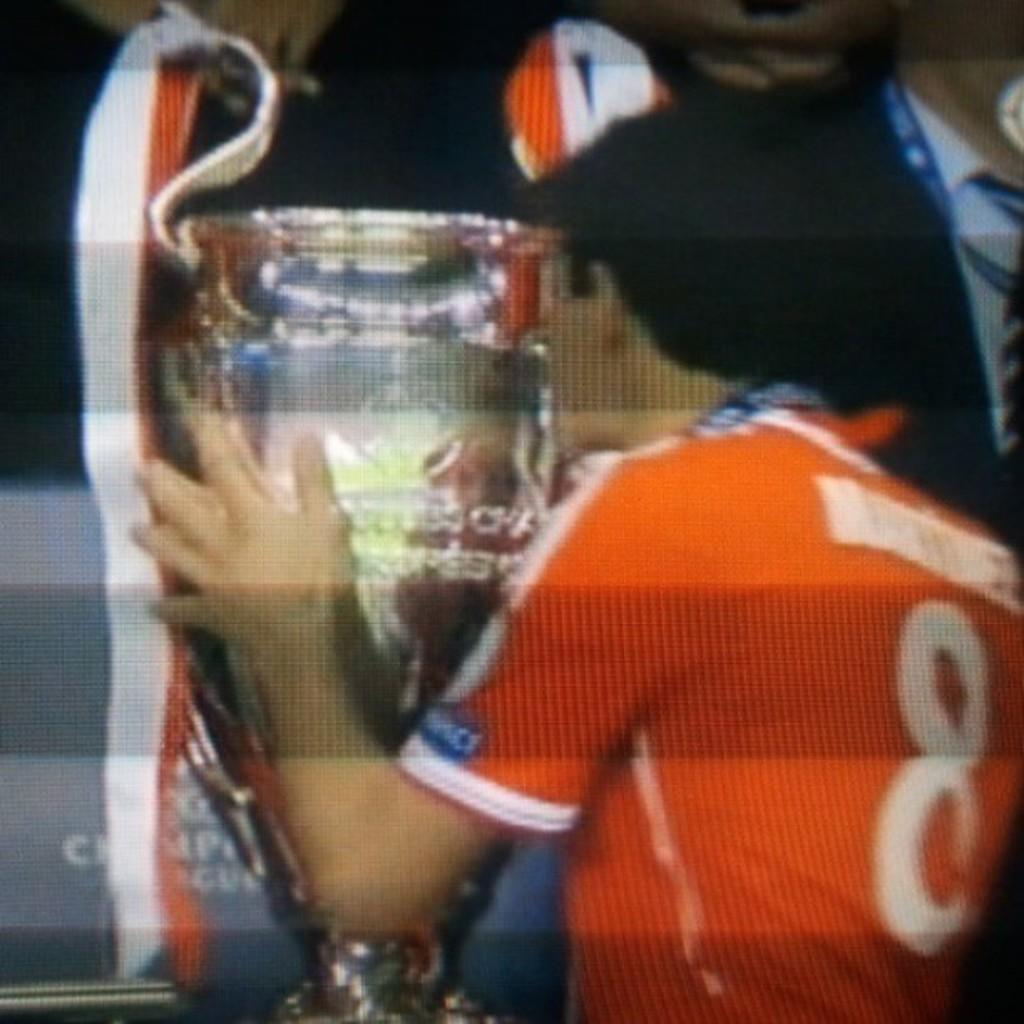<image>
Create a compact narrative representing the image presented. the man wearing an orange colored number 8 jersey 